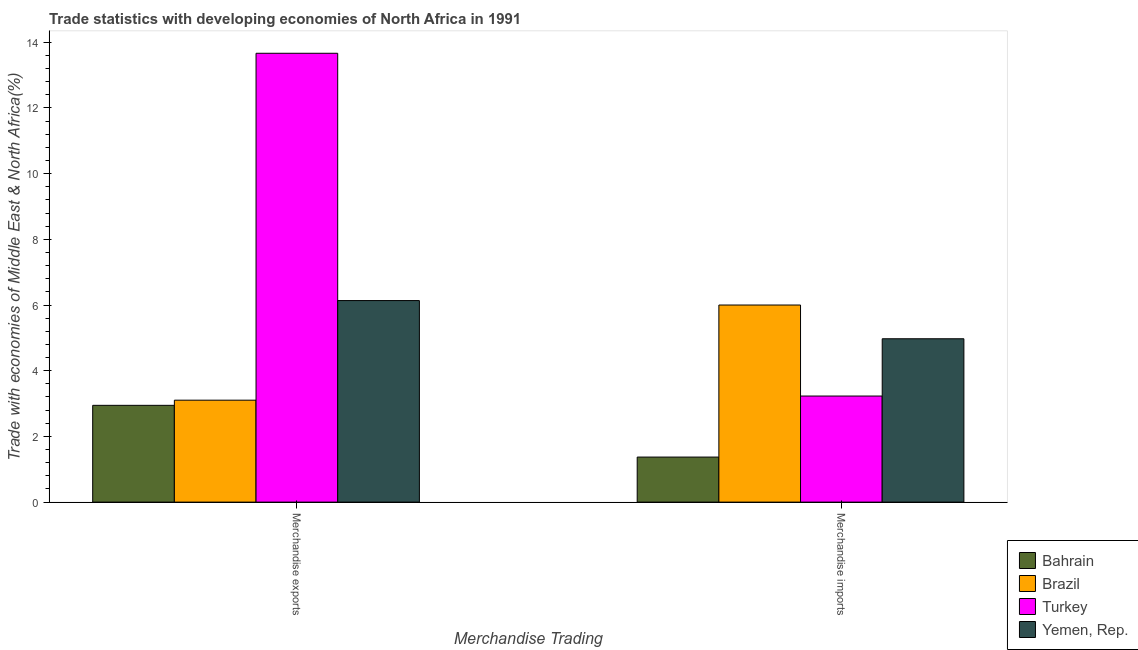How many different coloured bars are there?
Ensure brevity in your answer.  4. How many groups of bars are there?
Provide a succinct answer. 2. Are the number of bars per tick equal to the number of legend labels?
Offer a very short reply. Yes. How many bars are there on the 1st tick from the left?
Make the answer very short. 4. How many bars are there on the 2nd tick from the right?
Your answer should be compact. 4. What is the merchandise exports in Yemen, Rep.?
Offer a terse response. 6.14. Across all countries, what is the maximum merchandise imports?
Give a very brief answer. 6. Across all countries, what is the minimum merchandise imports?
Give a very brief answer. 1.37. In which country was the merchandise exports maximum?
Keep it short and to the point. Turkey. In which country was the merchandise imports minimum?
Make the answer very short. Bahrain. What is the total merchandise imports in the graph?
Offer a very short reply. 15.57. What is the difference between the merchandise imports in Turkey and that in Brazil?
Your answer should be compact. -2.77. What is the difference between the merchandise imports in Bahrain and the merchandise exports in Yemen, Rep.?
Your answer should be very brief. -4.76. What is the average merchandise imports per country?
Provide a short and direct response. 3.89. What is the difference between the merchandise exports and merchandise imports in Brazil?
Provide a short and direct response. -2.9. What is the ratio of the merchandise exports in Turkey to that in Brazil?
Provide a succinct answer. 4.4. Is the merchandise exports in Brazil less than that in Bahrain?
Offer a very short reply. No. In how many countries, is the merchandise imports greater than the average merchandise imports taken over all countries?
Your response must be concise. 2. What does the 4th bar from the left in Merchandise imports represents?
Provide a succinct answer. Yemen, Rep. Are all the bars in the graph horizontal?
Your answer should be very brief. No. How many countries are there in the graph?
Keep it short and to the point. 4. Does the graph contain grids?
Make the answer very short. No. How are the legend labels stacked?
Make the answer very short. Vertical. What is the title of the graph?
Provide a short and direct response. Trade statistics with developing economies of North Africa in 1991. Does "Solomon Islands" appear as one of the legend labels in the graph?
Offer a terse response. No. What is the label or title of the X-axis?
Keep it short and to the point. Merchandise Trading. What is the label or title of the Y-axis?
Your answer should be compact. Trade with economies of Middle East & North Africa(%). What is the Trade with economies of Middle East & North Africa(%) of Bahrain in Merchandise exports?
Your answer should be very brief. 2.95. What is the Trade with economies of Middle East & North Africa(%) of Brazil in Merchandise exports?
Make the answer very short. 3.1. What is the Trade with economies of Middle East & North Africa(%) of Turkey in Merchandise exports?
Offer a very short reply. 13.66. What is the Trade with economies of Middle East & North Africa(%) in Yemen, Rep. in Merchandise exports?
Provide a succinct answer. 6.14. What is the Trade with economies of Middle East & North Africa(%) of Bahrain in Merchandise imports?
Your answer should be very brief. 1.37. What is the Trade with economies of Middle East & North Africa(%) of Brazil in Merchandise imports?
Your response must be concise. 6. What is the Trade with economies of Middle East & North Africa(%) of Turkey in Merchandise imports?
Give a very brief answer. 3.23. What is the Trade with economies of Middle East & North Africa(%) of Yemen, Rep. in Merchandise imports?
Keep it short and to the point. 4.97. Across all Merchandise Trading, what is the maximum Trade with economies of Middle East & North Africa(%) in Bahrain?
Your answer should be compact. 2.95. Across all Merchandise Trading, what is the maximum Trade with economies of Middle East & North Africa(%) of Brazil?
Your answer should be very brief. 6. Across all Merchandise Trading, what is the maximum Trade with economies of Middle East & North Africa(%) in Turkey?
Ensure brevity in your answer.  13.66. Across all Merchandise Trading, what is the maximum Trade with economies of Middle East & North Africa(%) of Yemen, Rep.?
Your answer should be compact. 6.14. Across all Merchandise Trading, what is the minimum Trade with economies of Middle East & North Africa(%) of Bahrain?
Your response must be concise. 1.37. Across all Merchandise Trading, what is the minimum Trade with economies of Middle East & North Africa(%) in Brazil?
Your answer should be compact. 3.1. Across all Merchandise Trading, what is the minimum Trade with economies of Middle East & North Africa(%) in Turkey?
Ensure brevity in your answer.  3.23. Across all Merchandise Trading, what is the minimum Trade with economies of Middle East & North Africa(%) of Yemen, Rep.?
Give a very brief answer. 4.97. What is the total Trade with economies of Middle East & North Africa(%) in Bahrain in the graph?
Provide a short and direct response. 4.32. What is the total Trade with economies of Middle East & North Africa(%) in Brazil in the graph?
Provide a short and direct response. 9.1. What is the total Trade with economies of Middle East & North Africa(%) in Turkey in the graph?
Give a very brief answer. 16.89. What is the total Trade with economies of Middle East & North Africa(%) of Yemen, Rep. in the graph?
Your answer should be compact. 11.11. What is the difference between the Trade with economies of Middle East & North Africa(%) of Bahrain in Merchandise exports and that in Merchandise imports?
Offer a terse response. 1.57. What is the difference between the Trade with economies of Middle East & North Africa(%) of Brazil in Merchandise exports and that in Merchandise imports?
Make the answer very short. -2.9. What is the difference between the Trade with economies of Middle East & North Africa(%) of Turkey in Merchandise exports and that in Merchandise imports?
Offer a very short reply. 10.43. What is the difference between the Trade with economies of Middle East & North Africa(%) of Yemen, Rep. in Merchandise exports and that in Merchandise imports?
Ensure brevity in your answer.  1.16. What is the difference between the Trade with economies of Middle East & North Africa(%) in Bahrain in Merchandise exports and the Trade with economies of Middle East & North Africa(%) in Brazil in Merchandise imports?
Make the answer very short. -3.05. What is the difference between the Trade with economies of Middle East & North Africa(%) of Bahrain in Merchandise exports and the Trade with economies of Middle East & North Africa(%) of Turkey in Merchandise imports?
Your answer should be compact. -0.28. What is the difference between the Trade with economies of Middle East & North Africa(%) of Bahrain in Merchandise exports and the Trade with economies of Middle East & North Africa(%) of Yemen, Rep. in Merchandise imports?
Provide a succinct answer. -2.03. What is the difference between the Trade with economies of Middle East & North Africa(%) in Brazil in Merchandise exports and the Trade with economies of Middle East & North Africa(%) in Turkey in Merchandise imports?
Make the answer very short. -0.13. What is the difference between the Trade with economies of Middle East & North Africa(%) in Brazil in Merchandise exports and the Trade with economies of Middle East & North Africa(%) in Yemen, Rep. in Merchandise imports?
Your answer should be compact. -1.87. What is the difference between the Trade with economies of Middle East & North Africa(%) of Turkey in Merchandise exports and the Trade with economies of Middle East & North Africa(%) of Yemen, Rep. in Merchandise imports?
Keep it short and to the point. 8.69. What is the average Trade with economies of Middle East & North Africa(%) of Bahrain per Merchandise Trading?
Your answer should be compact. 2.16. What is the average Trade with economies of Middle East & North Africa(%) of Brazil per Merchandise Trading?
Your answer should be very brief. 4.55. What is the average Trade with economies of Middle East & North Africa(%) of Turkey per Merchandise Trading?
Your response must be concise. 8.45. What is the average Trade with economies of Middle East & North Africa(%) in Yemen, Rep. per Merchandise Trading?
Your answer should be very brief. 5.55. What is the difference between the Trade with economies of Middle East & North Africa(%) of Bahrain and Trade with economies of Middle East & North Africa(%) of Brazil in Merchandise exports?
Your answer should be very brief. -0.16. What is the difference between the Trade with economies of Middle East & North Africa(%) in Bahrain and Trade with economies of Middle East & North Africa(%) in Turkey in Merchandise exports?
Offer a terse response. -10.72. What is the difference between the Trade with economies of Middle East & North Africa(%) in Bahrain and Trade with economies of Middle East & North Africa(%) in Yemen, Rep. in Merchandise exports?
Your answer should be very brief. -3.19. What is the difference between the Trade with economies of Middle East & North Africa(%) in Brazil and Trade with economies of Middle East & North Africa(%) in Turkey in Merchandise exports?
Provide a short and direct response. -10.56. What is the difference between the Trade with economies of Middle East & North Africa(%) of Brazil and Trade with economies of Middle East & North Africa(%) of Yemen, Rep. in Merchandise exports?
Offer a terse response. -3.03. What is the difference between the Trade with economies of Middle East & North Africa(%) in Turkey and Trade with economies of Middle East & North Africa(%) in Yemen, Rep. in Merchandise exports?
Provide a succinct answer. 7.53. What is the difference between the Trade with economies of Middle East & North Africa(%) of Bahrain and Trade with economies of Middle East & North Africa(%) of Brazil in Merchandise imports?
Your answer should be very brief. -4.63. What is the difference between the Trade with economies of Middle East & North Africa(%) in Bahrain and Trade with economies of Middle East & North Africa(%) in Turkey in Merchandise imports?
Keep it short and to the point. -1.86. What is the difference between the Trade with economies of Middle East & North Africa(%) of Bahrain and Trade with economies of Middle East & North Africa(%) of Yemen, Rep. in Merchandise imports?
Provide a short and direct response. -3.6. What is the difference between the Trade with economies of Middle East & North Africa(%) of Brazil and Trade with economies of Middle East & North Africa(%) of Turkey in Merchandise imports?
Your response must be concise. 2.77. What is the difference between the Trade with economies of Middle East & North Africa(%) of Brazil and Trade with economies of Middle East & North Africa(%) of Yemen, Rep. in Merchandise imports?
Offer a very short reply. 1.03. What is the difference between the Trade with economies of Middle East & North Africa(%) in Turkey and Trade with economies of Middle East & North Africa(%) in Yemen, Rep. in Merchandise imports?
Your answer should be very brief. -1.74. What is the ratio of the Trade with economies of Middle East & North Africa(%) in Bahrain in Merchandise exports to that in Merchandise imports?
Provide a short and direct response. 2.15. What is the ratio of the Trade with economies of Middle East & North Africa(%) in Brazil in Merchandise exports to that in Merchandise imports?
Offer a very short reply. 0.52. What is the ratio of the Trade with economies of Middle East & North Africa(%) of Turkey in Merchandise exports to that in Merchandise imports?
Provide a succinct answer. 4.23. What is the ratio of the Trade with economies of Middle East & North Africa(%) in Yemen, Rep. in Merchandise exports to that in Merchandise imports?
Your response must be concise. 1.23. What is the difference between the highest and the second highest Trade with economies of Middle East & North Africa(%) in Bahrain?
Your answer should be compact. 1.57. What is the difference between the highest and the second highest Trade with economies of Middle East & North Africa(%) of Brazil?
Your response must be concise. 2.9. What is the difference between the highest and the second highest Trade with economies of Middle East & North Africa(%) of Turkey?
Provide a short and direct response. 10.43. What is the difference between the highest and the second highest Trade with economies of Middle East & North Africa(%) in Yemen, Rep.?
Offer a terse response. 1.16. What is the difference between the highest and the lowest Trade with economies of Middle East & North Africa(%) in Bahrain?
Your response must be concise. 1.57. What is the difference between the highest and the lowest Trade with economies of Middle East & North Africa(%) of Brazil?
Offer a terse response. 2.9. What is the difference between the highest and the lowest Trade with economies of Middle East & North Africa(%) of Turkey?
Ensure brevity in your answer.  10.43. What is the difference between the highest and the lowest Trade with economies of Middle East & North Africa(%) of Yemen, Rep.?
Make the answer very short. 1.16. 